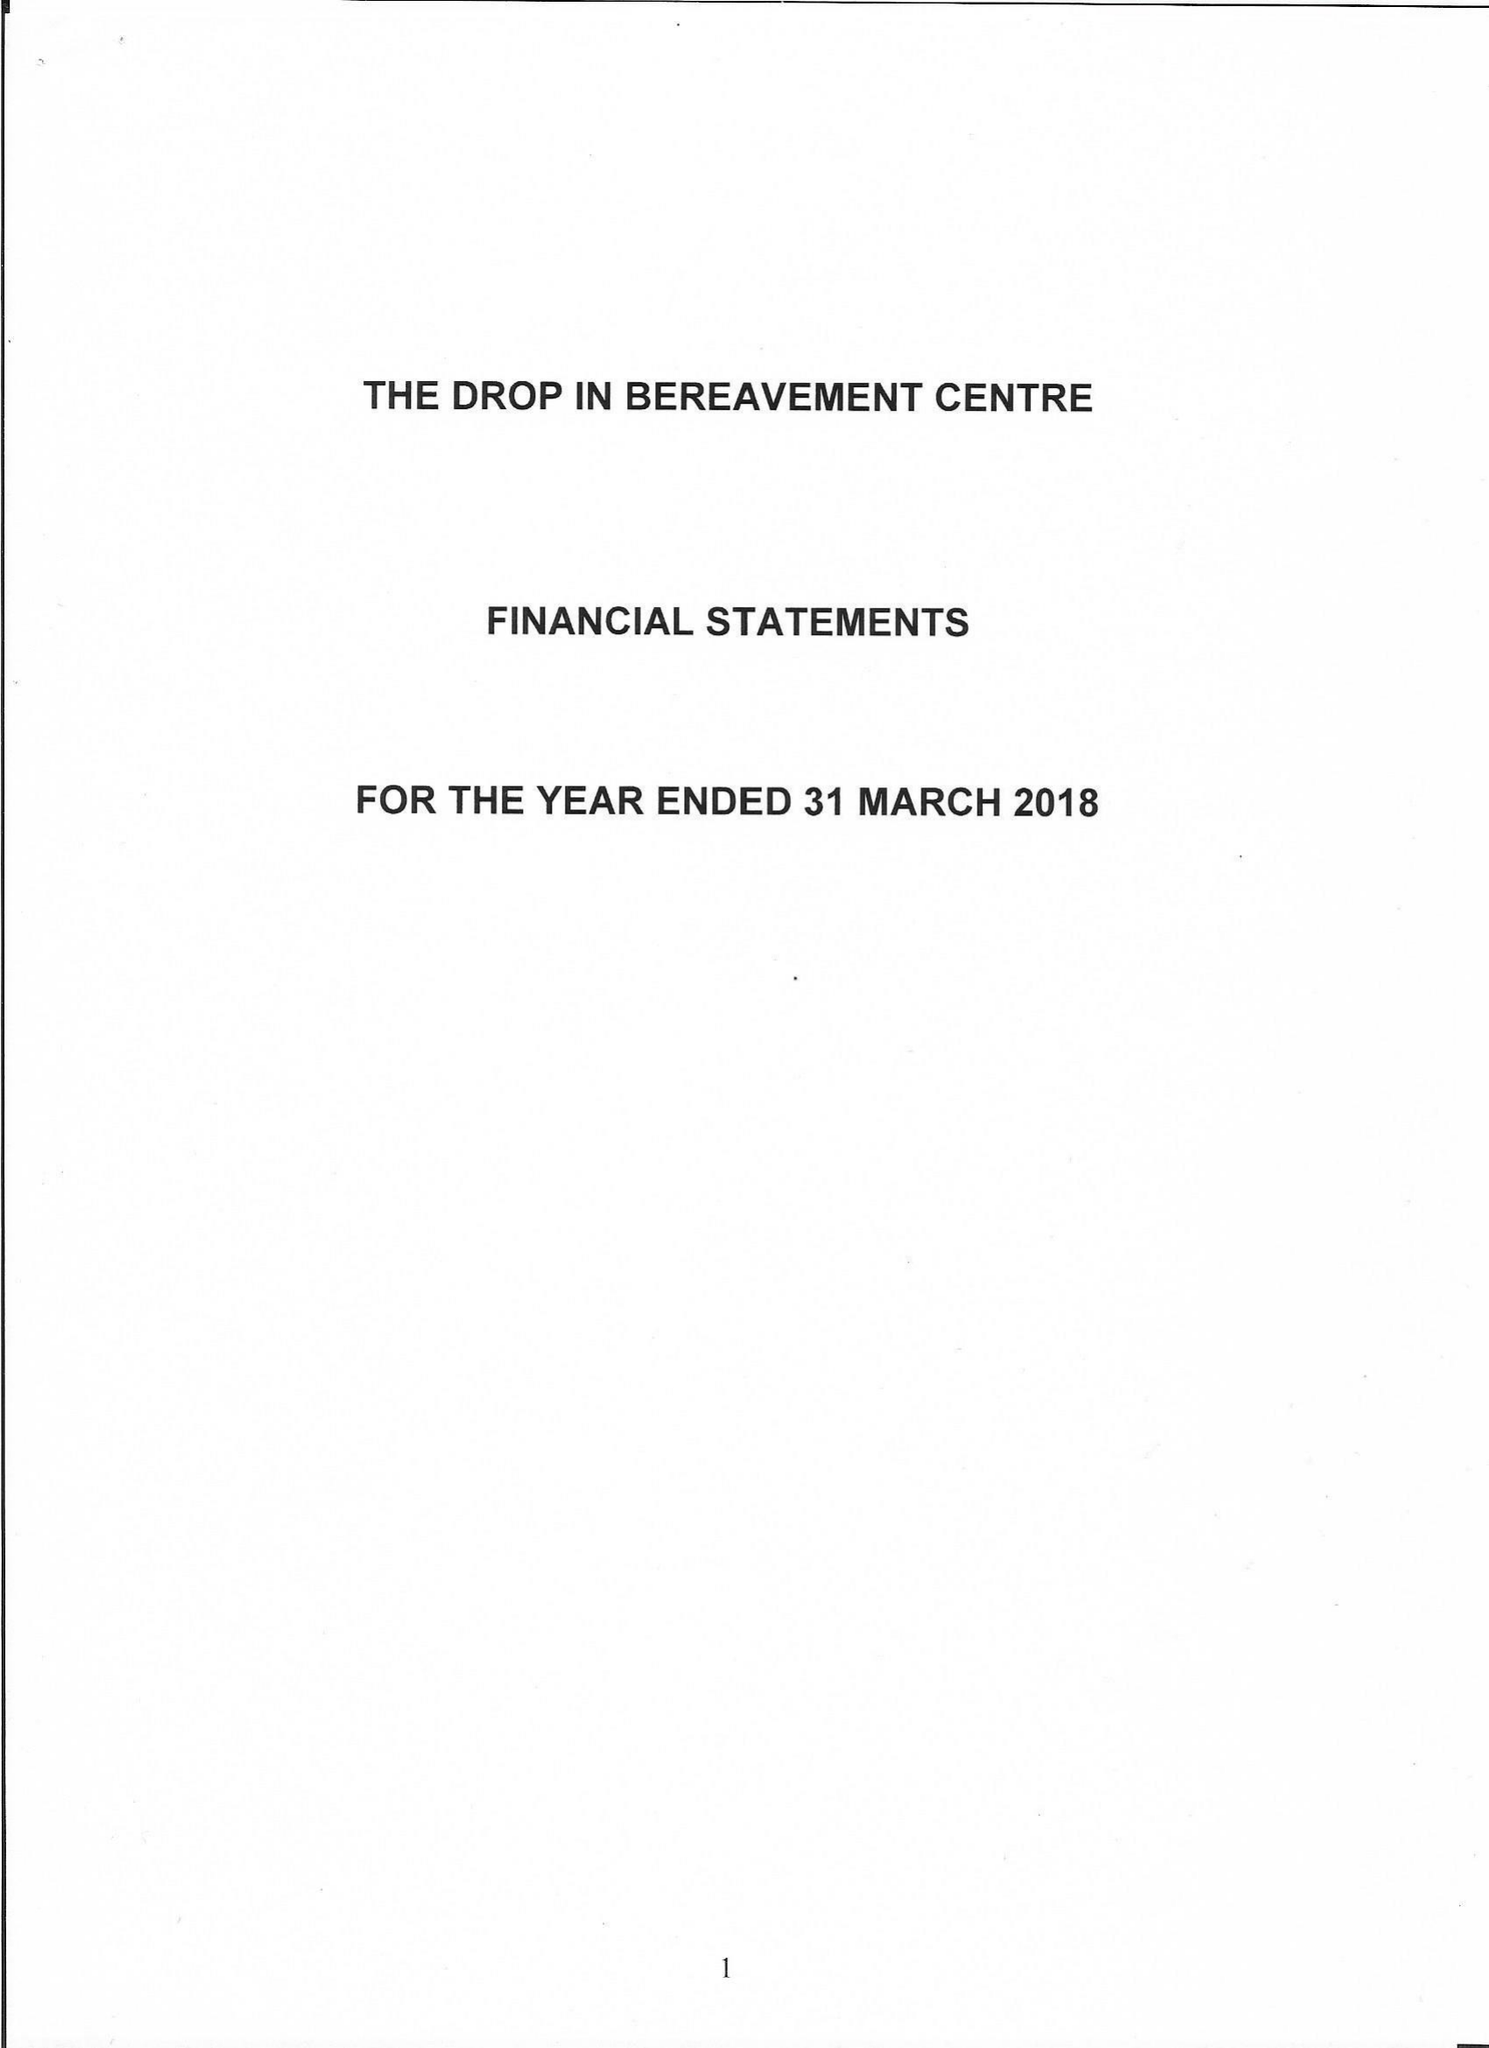What is the value for the charity_name?
Answer the question using a single word or phrase. The Drop In Bereavement Centre 